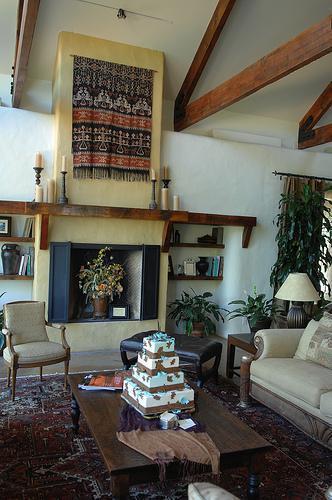How many tiers is the cake?
Give a very brief answer. 4. 